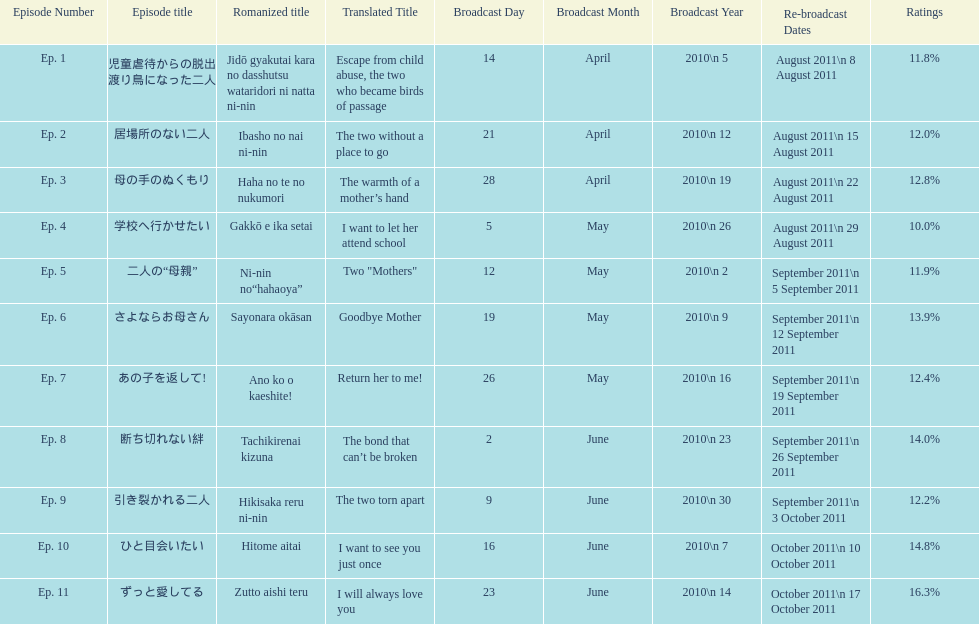What was the name of the first episode of this show? 児童虐待からの脱出 渡り鳥になった二人. 